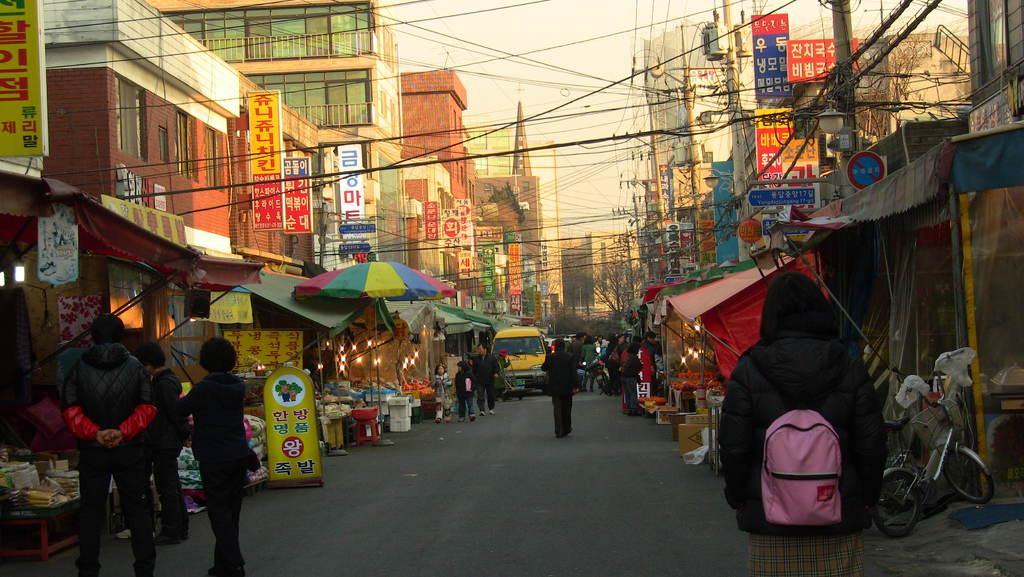Can you describe this image briefly? In this image on the right side and left side there are some stores, and some people are selling somethings. And also there are some buildings, poles, wires. In the center there are some persons walking and also some vehicles, tents, boards. On the boards there is text, at the bottom there is road and on the right side and left side there are some boxes, cycle, lights, tents. At the top of the image there is sky. 